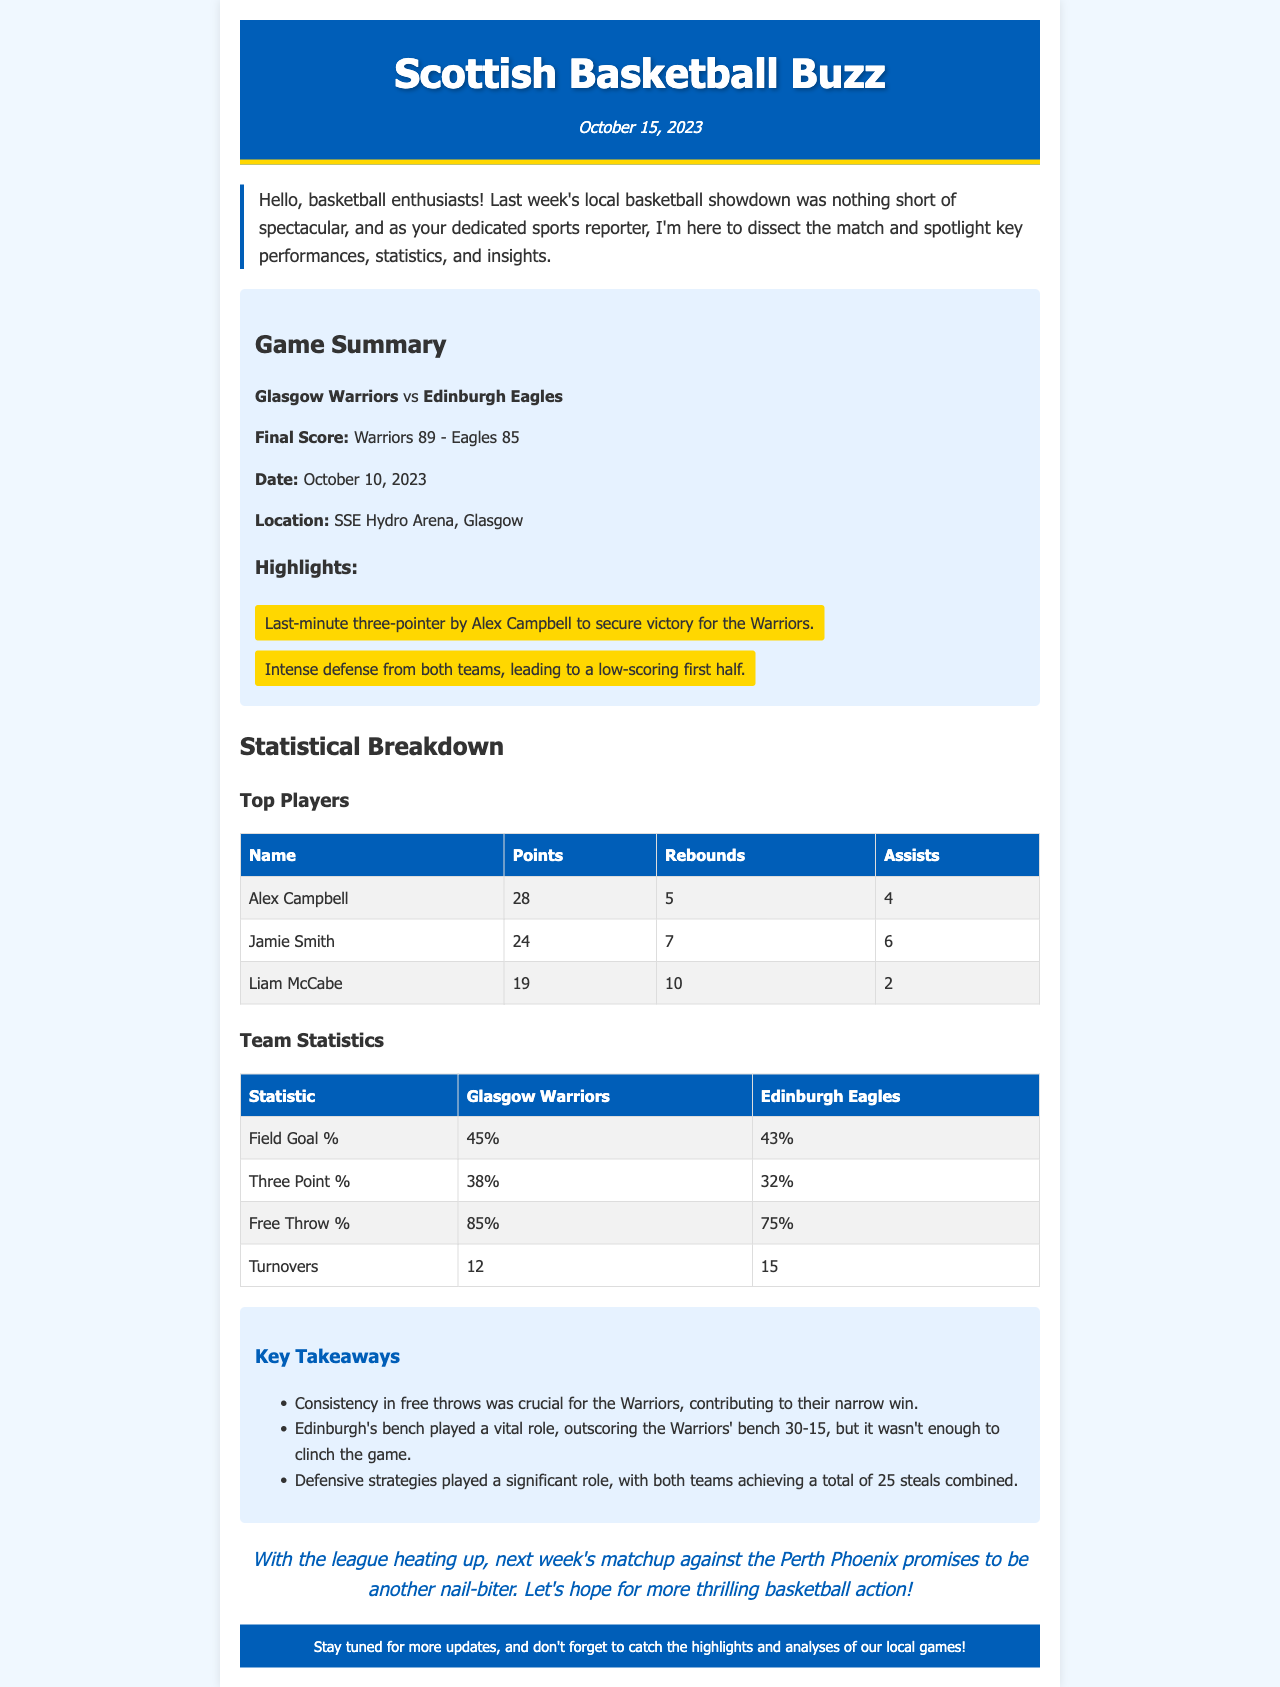What was the final score of the game? The final score is presented in the document as the key outcome of the match between the two teams.
Answer: Warriors 89 - Eagles 85 Who scored the most points in the game? The player with the highest points is listed in the top players section, showing individual achievements.
Answer: Alex Campbell What date did the game take place? The date of the game is explicitly stated in the game summary section of the newsletter.
Answer: October 10, 2023 Which team had a higher field goal percentage? Team statistics indicate the field goal percentages for both teams, allowing for comparison.
Answer: Glasgow Warriors How many rebounds did Liam McCabe have? The rebounds stat for each top player is provided in the statistical breakdown section.
Answer: 10 What was Edinburgh Eagles' free throw percentage? The document provides specific percentages for each team in the team statistics table.
Answer: 75% Which player had the highest number of assists? The assists are listed for each top player, making it clear who excelled in this category.
Answer: Jamie Smith How many total steals did both teams achieve combined? The key takeaways summarize the defensive performance of both teams, including the total number of steals.
Answer: 25 What was a highlighted moment in the game? Highlights summarize key moments of the match, showcasing exciting events during the game.
Answer: Last-minute three-pointer by Alex Campbell 